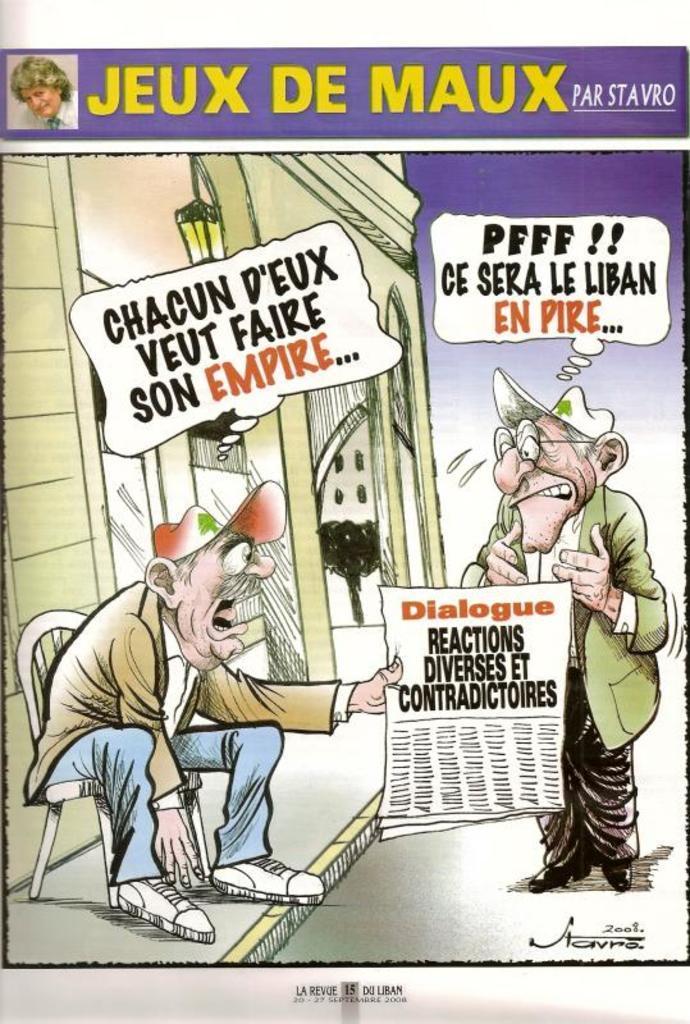Could you give a brief overview of what you see in this image? In the foreground of this poster, where we can see a man sitting on a chair holding a paper in his hand and there is another man standing and there is dialogue boxes on the top. 